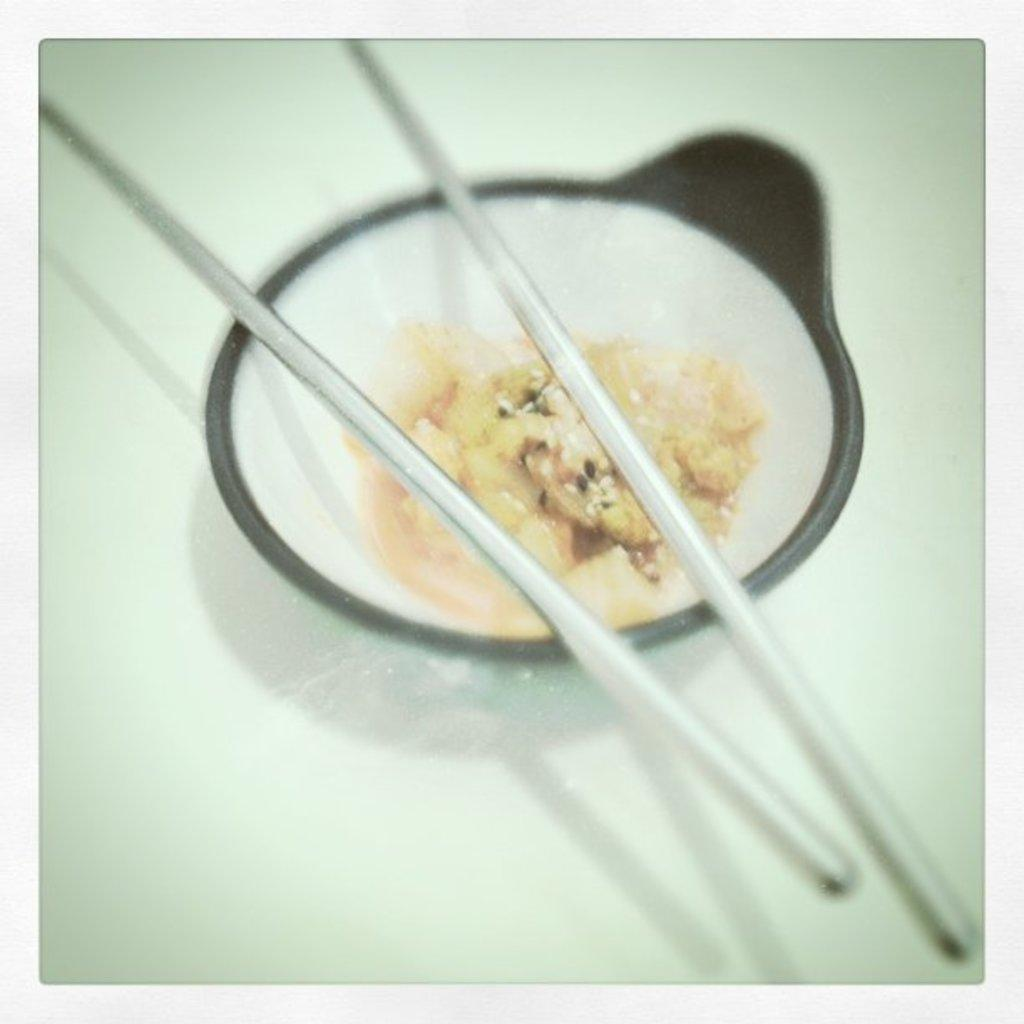What piece of furniture is visible in the image? There is a table in the image. What is placed on the table? There is a bowl on the table. What is inside the bowl? There is food in the bowl. What utensils are present in the image? Chopsticks are present in the image. What type of laughter can be heard coming from the stove in the image? There is no stove present in the image, and therefore no laughter can be heard. 